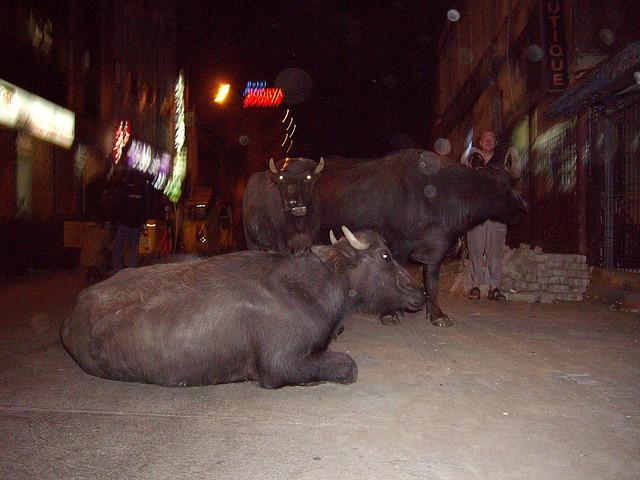Where is the animal currently sitting? Please explain your reasoning. street. The cow is in the middle of the road. 